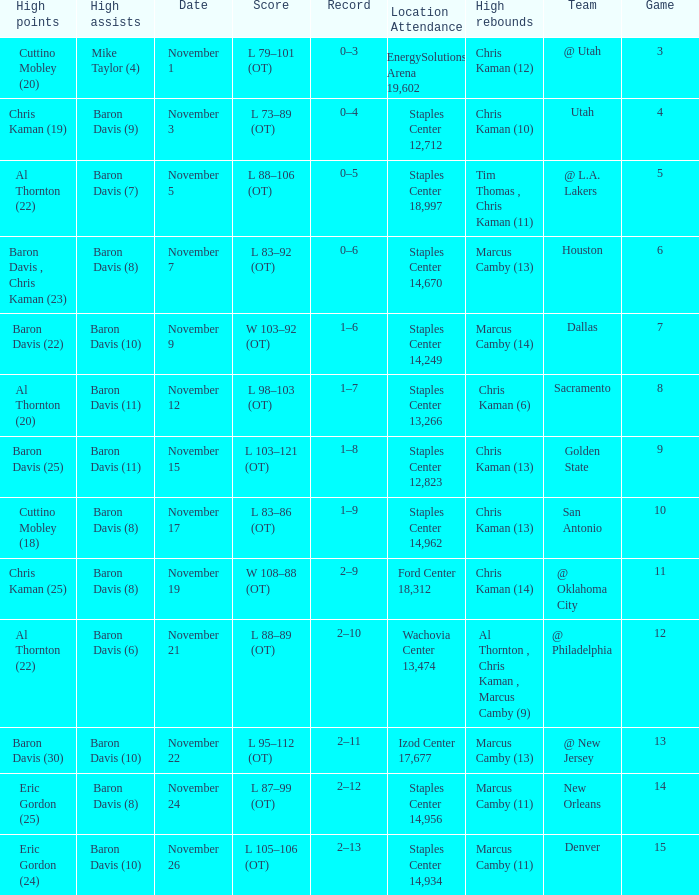Name the total number of score for staples center 13,266 1.0. 